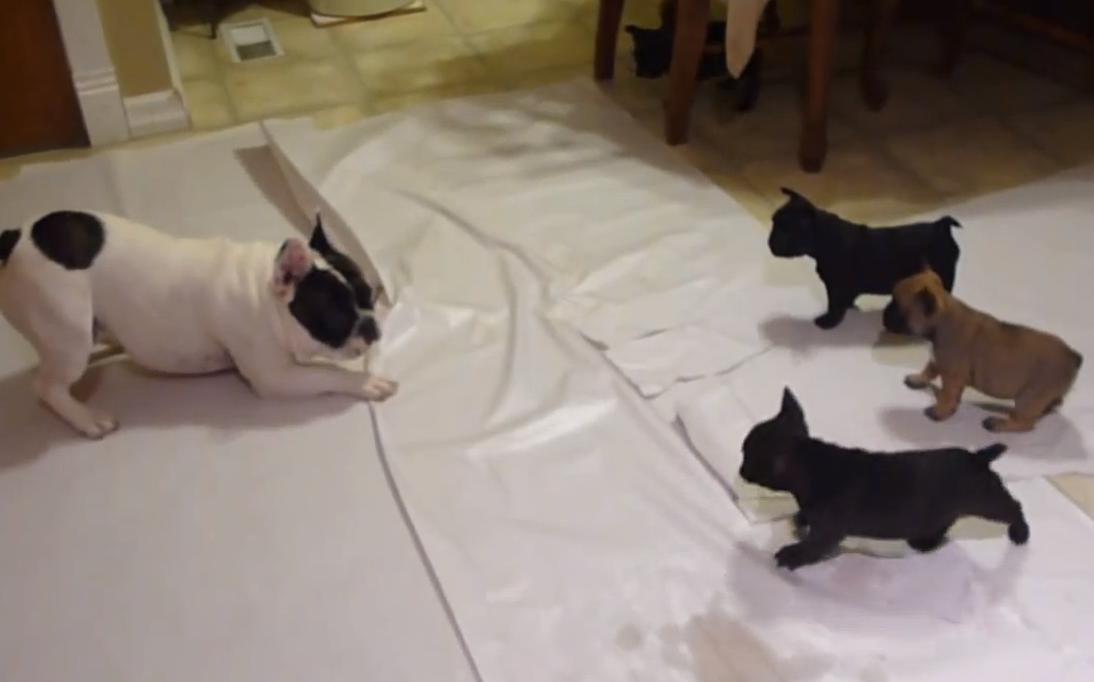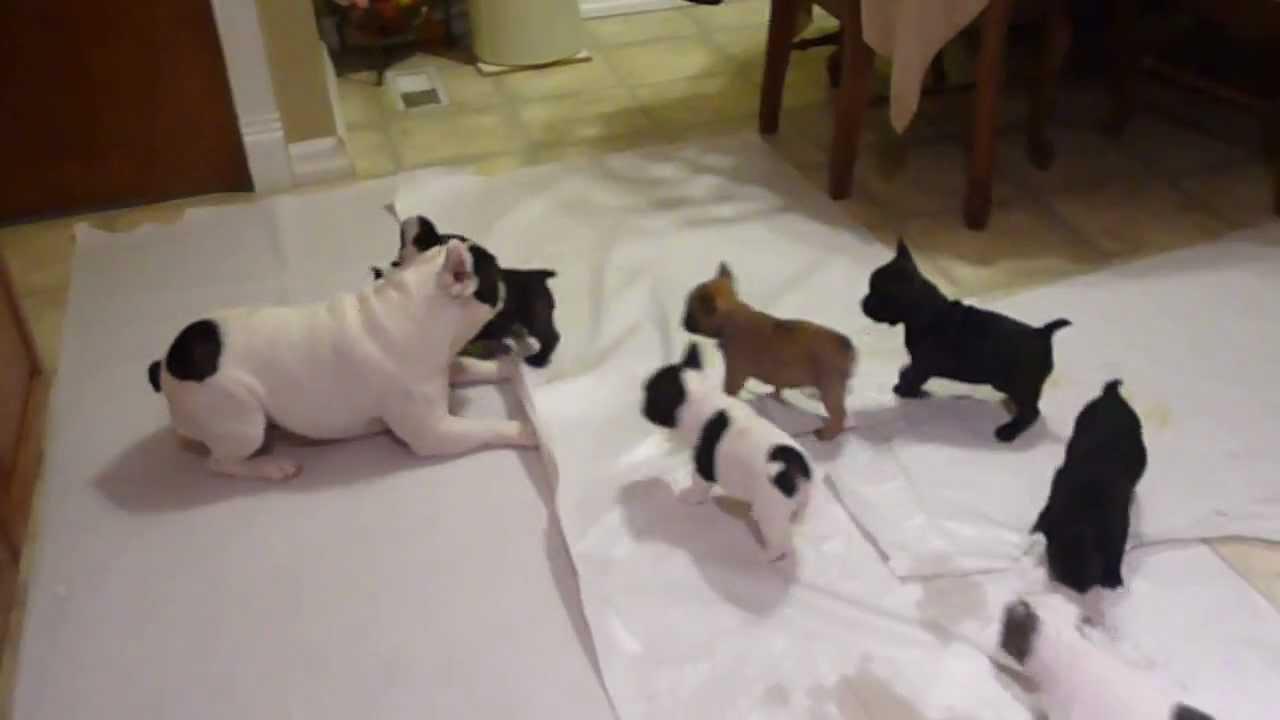The first image is the image on the left, the second image is the image on the right. For the images shown, is this caption "There are twp puppies in the image pair." true? Answer yes or no. No. The first image is the image on the left, the second image is the image on the right. Examine the images to the left and right. Is the description "Each image contains a single pug puppy, and each dog's gaze is in the same general direction." accurate? Answer yes or no. No. 